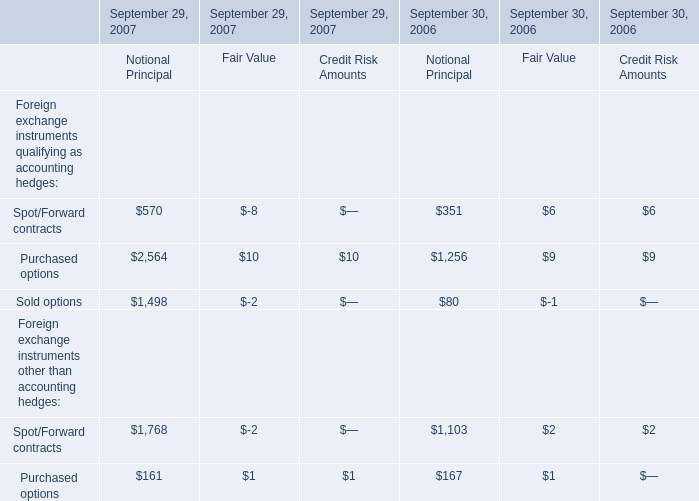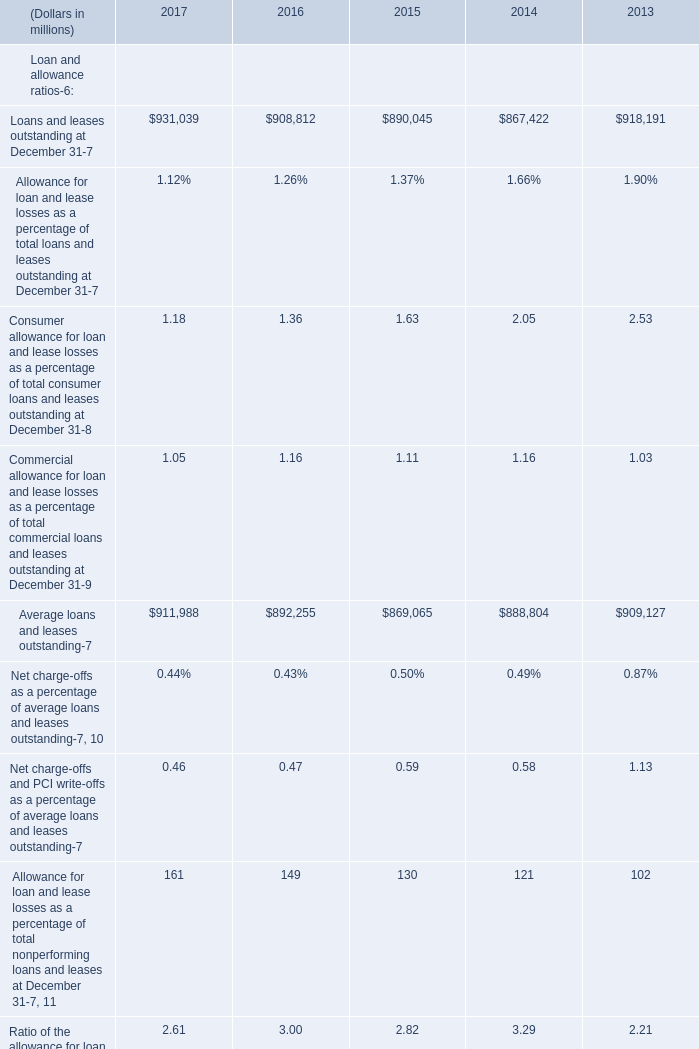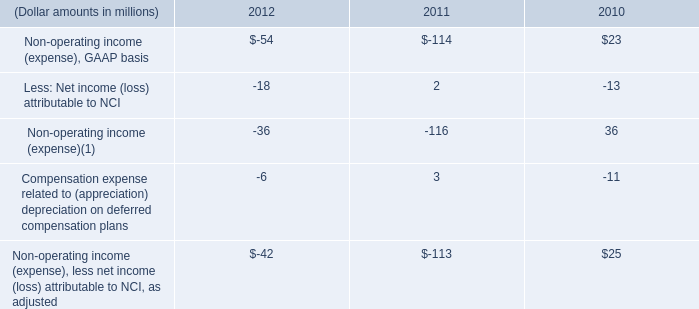In the year with lowest amount of loans and leases, what's the increasing rate of average loans and leases? 
Computations: ((869065 - 888804) / 888804)
Answer: -0.02221. 